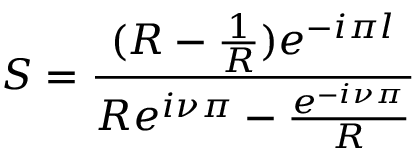Convert formula to latex. <formula><loc_0><loc_0><loc_500><loc_500>S = \frac { ( R - \frac { 1 } { R } ) e ^ { - i \pi l } } { R e ^ { i \nu \pi } - \frac { e ^ { - i \nu \pi } } { R } }</formula> 